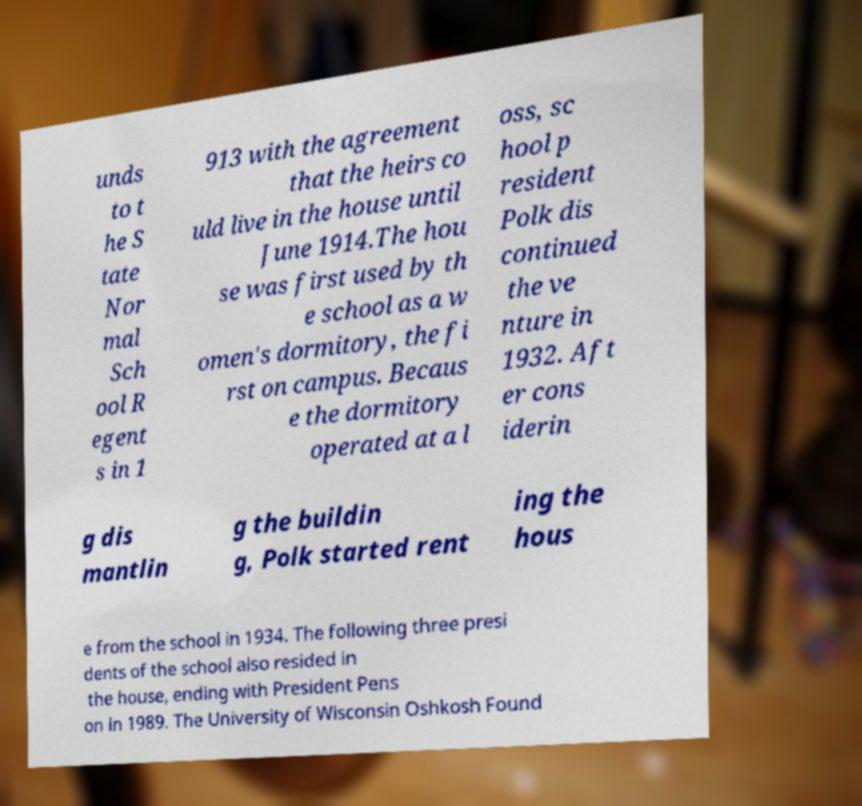There's text embedded in this image that I need extracted. Can you transcribe it verbatim? unds to t he S tate Nor mal Sch ool R egent s in 1 913 with the agreement that the heirs co uld live in the house until June 1914.The hou se was first used by th e school as a w omen's dormitory, the fi rst on campus. Becaus e the dormitory operated at a l oss, sc hool p resident Polk dis continued the ve nture in 1932. Aft er cons iderin g dis mantlin g the buildin g, Polk started rent ing the hous e from the school in 1934. The following three presi dents of the school also resided in the house, ending with President Pens on in 1989. The University of Wisconsin Oshkosh Found 